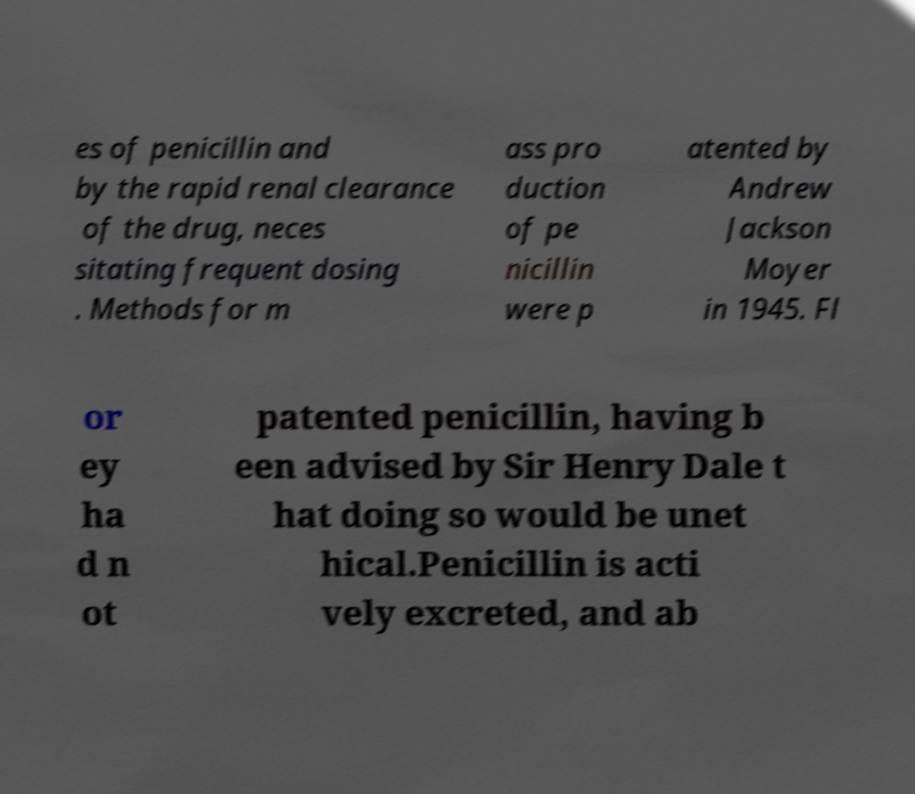Please identify and transcribe the text found in this image. es of penicillin and by the rapid renal clearance of the drug, neces sitating frequent dosing . Methods for m ass pro duction of pe nicillin were p atented by Andrew Jackson Moyer in 1945. Fl or ey ha d n ot patented penicillin, having b een advised by Sir Henry Dale t hat doing so would be unet hical.Penicillin is acti vely excreted, and ab 